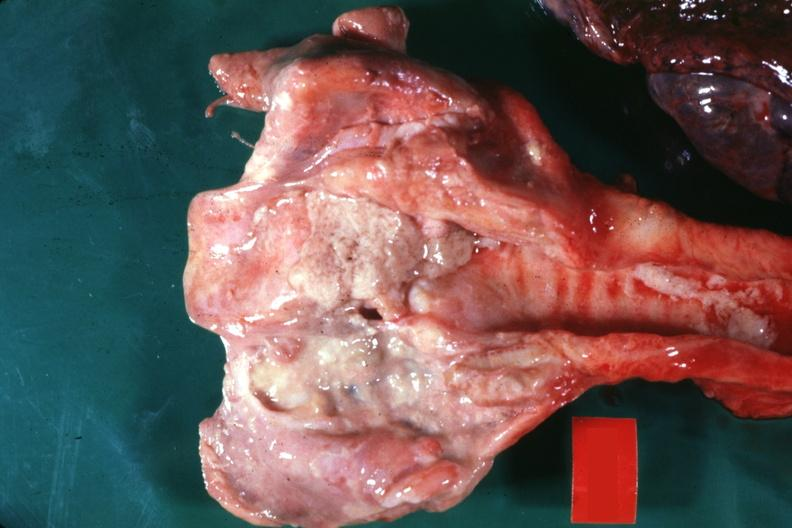what does this image show?
Answer the question using a single word or phrase. Large ulcers probably secondary to tube 